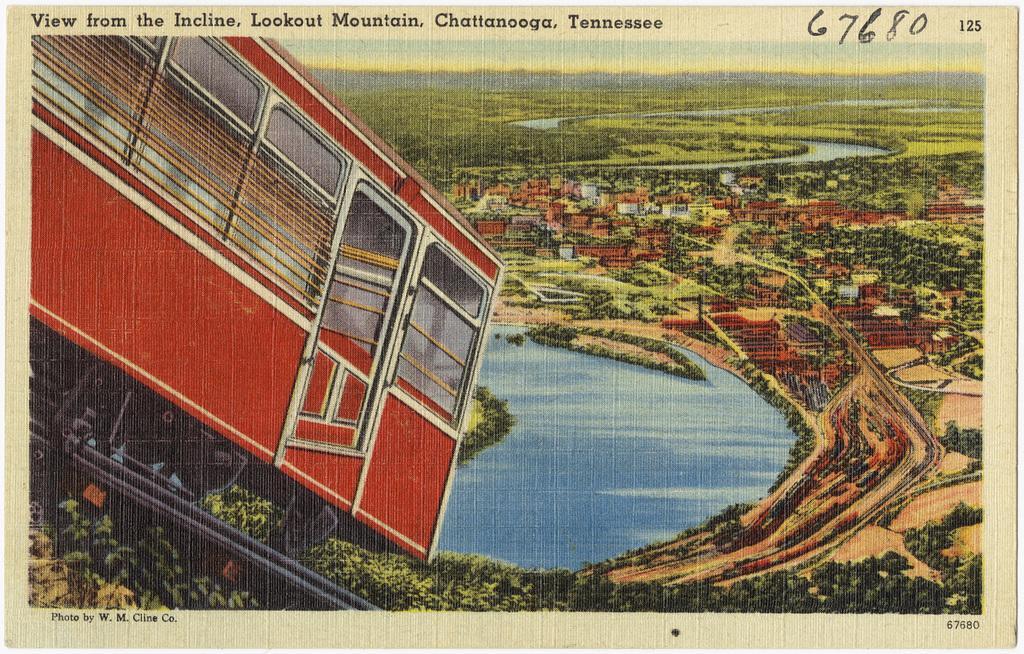Where was this located?
Provide a succinct answer. Lookout mountain, chattanooga, tennessee. What is this mountain called?
Provide a short and direct response. Lookout mountain. 